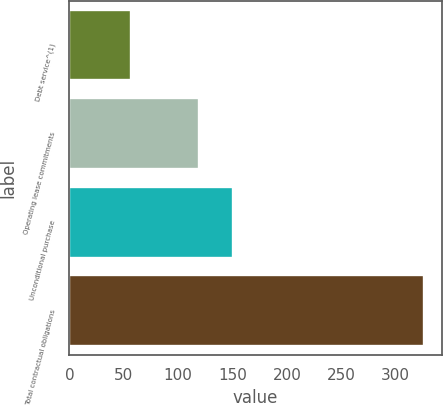Convert chart to OTSL. <chart><loc_0><loc_0><loc_500><loc_500><bar_chart><fcel>Debt service^(1)<fcel>Operating lease commitments<fcel>Unconditional purchase<fcel>Total contractual obligations<nl><fcel>56.8<fcel>119.3<fcel>150<fcel>326.1<nl></chart> 